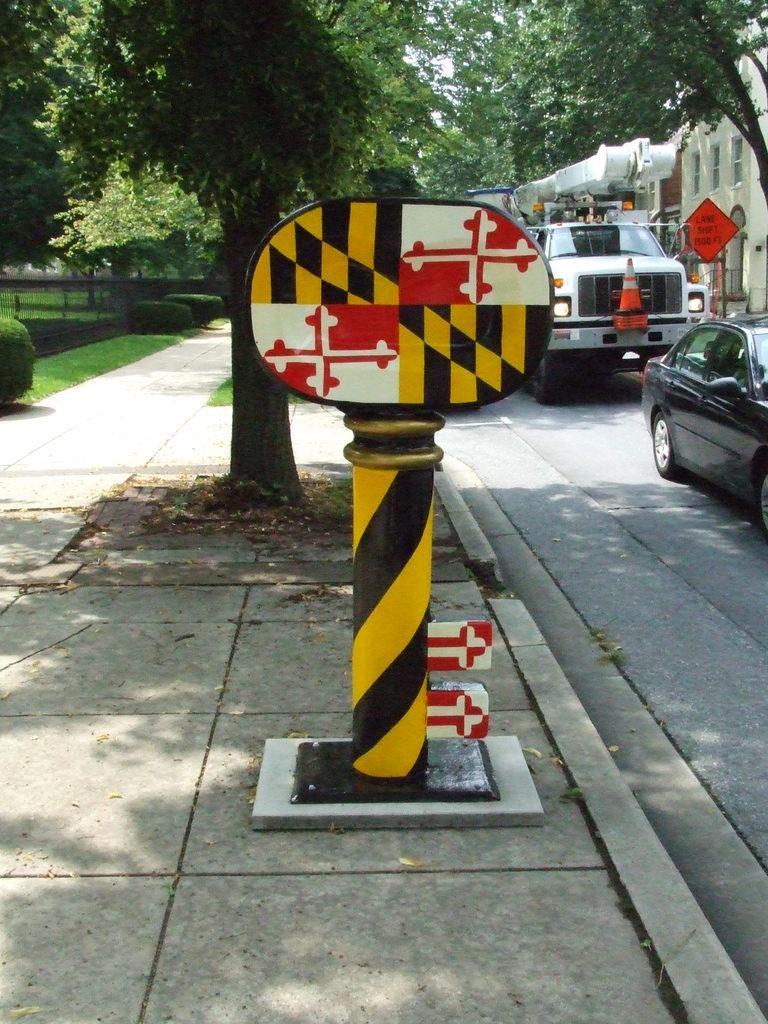Could you give a brief overview of what you see in this image? In the foreground of the image, we can see a sign board on the pavement. In the background, we can see trees, fence, grassy land and plants. Right side of the image, we can see vehicles on the road. Behind the vehicles, we can see a sign board and a building. 